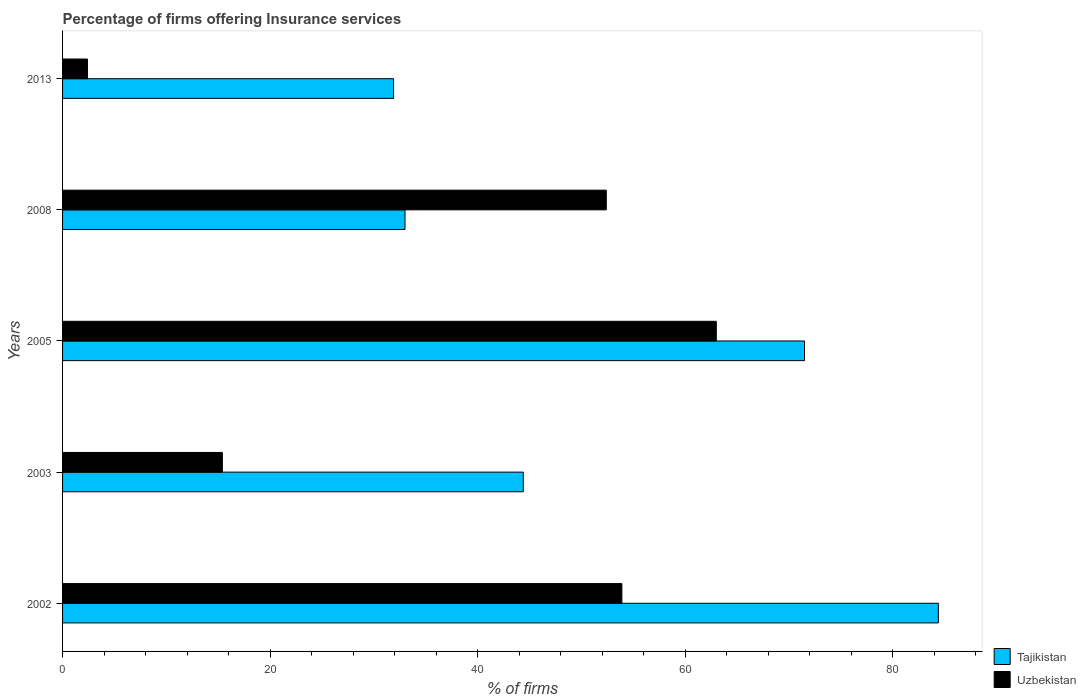How many different coloured bars are there?
Keep it short and to the point. 2. Are the number of bars on each tick of the Y-axis equal?
Offer a very short reply. Yes. How many bars are there on the 1st tick from the top?
Your answer should be compact. 2. Across all years, what is the maximum percentage of firms offering insurance services in Uzbekistan?
Your answer should be compact. 63. Across all years, what is the minimum percentage of firms offering insurance services in Tajikistan?
Provide a succinct answer. 31.9. In which year was the percentage of firms offering insurance services in Tajikistan minimum?
Make the answer very short. 2013. What is the total percentage of firms offering insurance services in Tajikistan in the graph?
Offer a terse response. 265.2. What is the difference between the percentage of firms offering insurance services in Tajikistan in 2003 and that in 2005?
Offer a very short reply. -27.1. What is the difference between the percentage of firms offering insurance services in Uzbekistan in 2005 and the percentage of firms offering insurance services in Tajikistan in 2002?
Provide a short and direct response. -21.4. What is the average percentage of firms offering insurance services in Tajikistan per year?
Give a very brief answer. 53.04. In how many years, is the percentage of firms offering insurance services in Uzbekistan greater than 4 %?
Offer a terse response. 4. What is the ratio of the percentage of firms offering insurance services in Tajikistan in 2002 to that in 2013?
Ensure brevity in your answer.  2.65. Is the percentage of firms offering insurance services in Uzbekistan in 2003 less than that in 2008?
Ensure brevity in your answer.  Yes. What is the difference between the highest and the second highest percentage of firms offering insurance services in Uzbekistan?
Provide a succinct answer. 9.1. What is the difference between the highest and the lowest percentage of firms offering insurance services in Tajikistan?
Your response must be concise. 52.5. In how many years, is the percentage of firms offering insurance services in Tajikistan greater than the average percentage of firms offering insurance services in Tajikistan taken over all years?
Give a very brief answer. 2. What does the 1st bar from the top in 2008 represents?
Offer a very short reply. Uzbekistan. What does the 1st bar from the bottom in 2005 represents?
Keep it short and to the point. Tajikistan. How many bars are there?
Provide a short and direct response. 10. Are all the bars in the graph horizontal?
Give a very brief answer. Yes. How many years are there in the graph?
Your answer should be very brief. 5. What is the difference between two consecutive major ticks on the X-axis?
Ensure brevity in your answer.  20. How many legend labels are there?
Offer a very short reply. 2. How are the legend labels stacked?
Provide a succinct answer. Vertical. What is the title of the graph?
Provide a short and direct response. Percentage of firms offering Insurance services. Does "Romania" appear as one of the legend labels in the graph?
Your answer should be compact. No. What is the label or title of the X-axis?
Make the answer very short. % of firms. What is the % of firms in Tajikistan in 2002?
Provide a short and direct response. 84.4. What is the % of firms of Uzbekistan in 2002?
Give a very brief answer. 53.9. What is the % of firms of Tajikistan in 2003?
Your answer should be compact. 44.4. What is the % of firms of Tajikistan in 2005?
Keep it short and to the point. 71.5. What is the % of firms of Tajikistan in 2008?
Offer a very short reply. 33. What is the % of firms in Uzbekistan in 2008?
Offer a terse response. 52.4. What is the % of firms of Tajikistan in 2013?
Make the answer very short. 31.9. Across all years, what is the maximum % of firms in Tajikistan?
Ensure brevity in your answer.  84.4. Across all years, what is the minimum % of firms of Tajikistan?
Your response must be concise. 31.9. What is the total % of firms of Tajikistan in the graph?
Your answer should be compact. 265.2. What is the total % of firms in Uzbekistan in the graph?
Offer a terse response. 187.1. What is the difference between the % of firms in Uzbekistan in 2002 and that in 2003?
Provide a succinct answer. 38.5. What is the difference between the % of firms in Tajikistan in 2002 and that in 2008?
Offer a terse response. 51.4. What is the difference between the % of firms of Uzbekistan in 2002 and that in 2008?
Keep it short and to the point. 1.5. What is the difference between the % of firms in Tajikistan in 2002 and that in 2013?
Offer a very short reply. 52.5. What is the difference between the % of firms in Uzbekistan in 2002 and that in 2013?
Offer a terse response. 51.5. What is the difference between the % of firms in Tajikistan in 2003 and that in 2005?
Make the answer very short. -27.1. What is the difference between the % of firms of Uzbekistan in 2003 and that in 2005?
Your answer should be compact. -47.6. What is the difference between the % of firms in Tajikistan in 2003 and that in 2008?
Ensure brevity in your answer.  11.4. What is the difference between the % of firms of Uzbekistan in 2003 and that in 2008?
Your response must be concise. -37. What is the difference between the % of firms in Uzbekistan in 2003 and that in 2013?
Provide a short and direct response. 13. What is the difference between the % of firms of Tajikistan in 2005 and that in 2008?
Offer a very short reply. 38.5. What is the difference between the % of firms of Uzbekistan in 2005 and that in 2008?
Ensure brevity in your answer.  10.6. What is the difference between the % of firms in Tajikistan in 2005 and that in 2013?
Your answer should be very brief. 39.6. What is the difference between the % of firms of Uzbekistan in 2005 and that in 2013?
Keep it short and to the point. 60.6. What is the difference between the % of firms in Tajikistan in 2008 and that in 2013?
Your answer should be very brief. 1.1. What is the difference between the % of firms of Uzbekistan in 2008 and that in 2013?
Make the answer very short. 50. What is the difference between the % of firms in Tajikistan in 2002 and the % of firms in Uzbekistan in 2005?
Your answer should be very brief. 21.4. What is the difference between the % of firms in Tajikistan in 2002 and the % of firms in Uzbekistan in 2008?
Your answer should be very brief. 32. What is the difference between the % of firms of Tajikistan in 2003 and the % of firms of Uzbekistan in 2005?
Provide a short and direct response. -18.6. What is the difference between the % of firms of Tajikistan in 2003 and the % of firms of Uzbekistan in 2013?
Offer a very short reply. 42. What is the difference between the % of firms of Tajikistan in 2005 and the % of firms of Uzbekistan in 2013?
Offer a very short reply. 69.1. What is the difference between the % of firms in Tajikistan in 2008 and the % of firms in Uzbekistan in 2013?
Ensure brevity in your answer.  30.6. What is the average % of firms of Tajikistan per year?
Give a very brief answer. 53.04. What is the average % of firms of Uzbekistan per year?
Provide a succinct answer. 37.42. In the year 2002, what is the difference between the % of firms of Tajikistan and % of firms of Uzbekistan?
Provide a succinct answer. 30.5. In the year 2003, what is the difference between the % of firms in Tajikistan and % of firms in Uzbekistan?
Your answer should be compact. 29. In the year 2008, what is the difference between the % of firms in Tajikistan and % of firms in Uzbekistan?
Your answer should be very brief. -19.4. In the year 2013, what is the difference between the % of firms of Tajikistan and % of firms of Uzbekistan?
Offer a terse response. 29.5. What is the ratio of the % of firms in Tajikistan in 2002 to that in 2003?
Make the answer very short. 1.9. What is the ratio of the % of firms in Uzbekistan in 2002 to that in 2003?
Ensure brevity in your answer.  3.5. What is the ratio of the % of firms in Tajikistan in 2002 to that in 2005?
Provide a short and direct response. 1.18. What is the ratio of the % of firms of Uzbekistan in 2002 to that in 2005?
Your answer should be very brief. 0.86. What is the ratio of the % of firms in Tajikistan in 2002 to that in 2008?
Your response must be concise. 2.56. What is the ratio of the % of firms of Uzbekistan in 2002 to that in 2008?
Provide a short and direct response. 1.03. What is the ratio of the % of firms of Tajikistan in 2002 to that in 2013?
Your answer should be very brief. 2.65. What is the ratio of the % of firms in Uzbekistan in 2002 to that in 2013?
Offer a terse response. 22.46. What is the ratio of the % of firms in Tajikistan in 2003 to that in 2005?
Give a very brief answer. 0.62. What is the ratio of the % of firms in Uzbekistan in 2003 to that in 2005?
Make the answer very short. 0.24. What is the ratio of the % of firms in Tajikistan in 2003 to that in 2008?
Keep it short and to the point. 1.35. What is the ratio of the % of firms of Uzbekistan in 2003 to that in 2008?
Ensure brevity in your answer.  0.29. What is the ratio of the % of firms in Tajikistan in 2003 to that in 2013?
Offer a terse response. 1.39. What is the ratio of the % of firms of Uzbekistan in 2003 to that in 2013?
Provide a succinct answer. 6.42. What is the ratio of the % of firms in Tajikistan in 2005 to that in 2008?
Offer a very short reply. 2.17. What is the ratio of the % of firms in Uzbekistan in 2005 to that in 2008?
Provide a short and direct response. 1.2. What is the ratio of the % of firms of Tajikistan in 2005 to that in 2013?
Make the answer very short. 2.24. What is the ratio of the % of firms in Uzbekistan in 2005 to that in 2013?
Provide a short and direct response. 26.25. What is the ratio of the % of firms in Tajikistan in 2008 to that in 2013?
Give a very brief answer. 1.03. What is the ratio of the % of firms in Uzbekistan in 2008 to that in 2013?
Offer a very short reply. 21.83. What is the difference between the highest and the second highest % of firms in Tajikistan?
Offer a very short reply. 12.9. What is the difference between the highest and the second highest % of firms of Uzbekistan?
Your answer should be compact. 9.1. What is the difference between the highest and the lowest % of firms of Tajikistan?
Your answer should be very brief. 52.5. What is the difference between the highest and the lowest % of firms of Uzbekistan?
Provide a succinct answer. 60.6. 